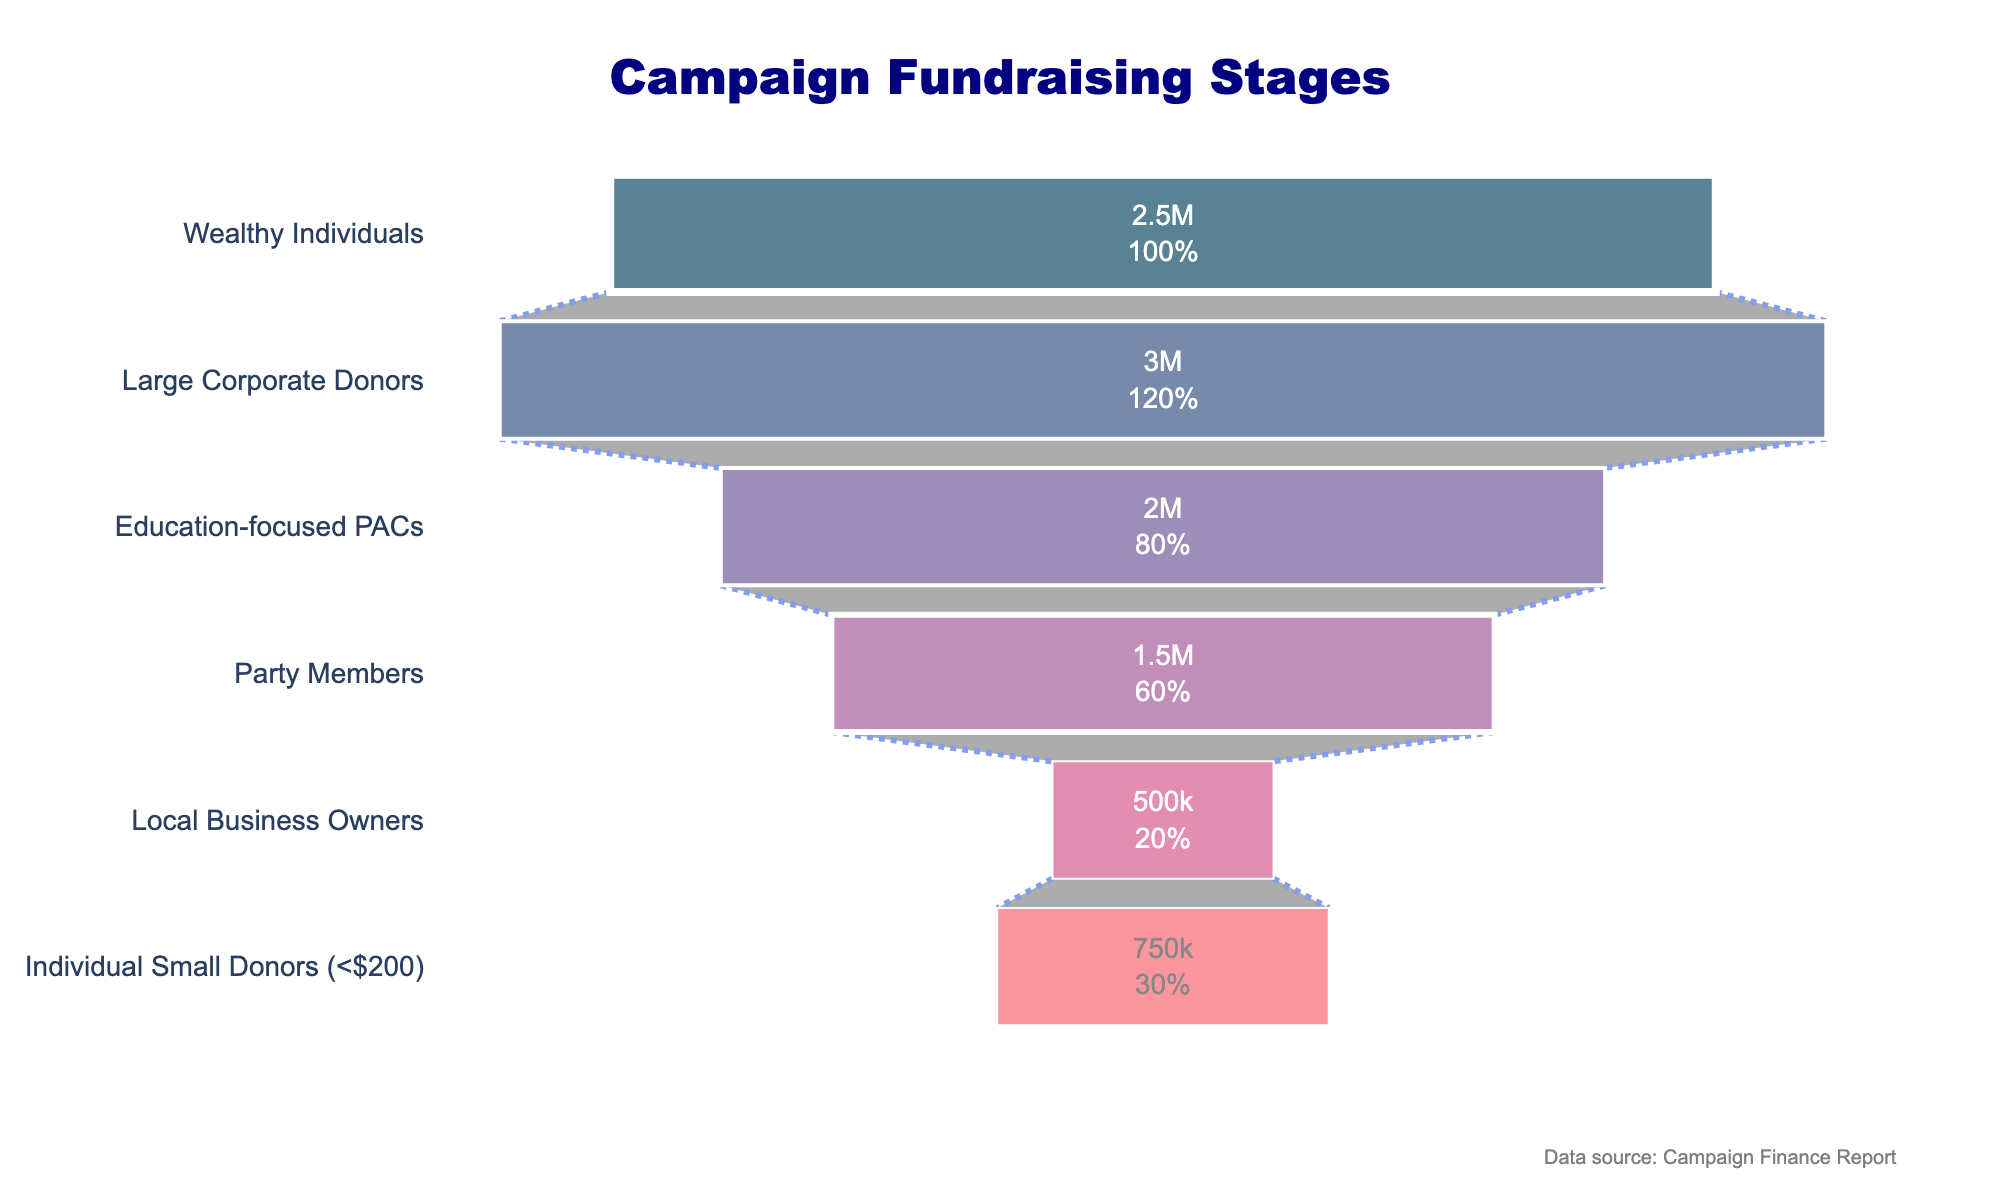What's the title of the funnel chart? The title is typically presented at the top of the chart. It should be concise and summarize the subject of the chart. In this case, the title is "Campaign Fundraising Stages".
Answer: Campaign Fundraising Stages How many stages are represented in the funnel chart? By looking at the number of categories listed horizontally in the funnel chart, we can count the distinct stages.
Answer: 6 Which stage represents the largest contribution in amount? We observe the funnel chart and identify the longest horizontal bar. The stage connected with this bar shows the largest contribution.
Answer: Large Corporate Donors What is the total amount raised from individual small donors and local business owners combined? First, identify the amounts for "Individual Small Donors" and "Local Business Owners" from the chart. Then, add these amounts together: $750,000 + $500,000 = $1,250,000.
Answer: $1,250,000 What percentage of the initial total does the "Large Corporate Donors" stage contribute? Find the amount contributed by "Large Corporate Donors" and the initial total. Use the percentage calculation: (3000000 / 10000000) * 100 = 30%.
Answer: 30% How does the amount contributed by wealthy individuals compare to that of education-focused PACs? Compare the lengths or values of the horizontal bars for "Wealthy Individuals" and "Education-focused PACs". The amount can be directly compared: $2,500,000 (Wealthy Individuals) is $500,000 less than $2,000,000 (Education-focused PACs).
Answer: $500,000 less What's the combined contribution amount from the top three stages? Add the amounts for the top three contributors: $3,000,000 (Large Corporate Donors) + $2,500,000 (Wealthy Individuals) + $2,000,000 (Education-focused PACs). The sum is $7,500,000.
Answer: $7,500,000 Which contributor group has more contributors, Party Members or Local Business Owners? Compare the number of contributors indicated for "Party Members" and "Local Business Owners". "Party Members" have 2,000 contributors, which is more than the 500 of "Local Business Owners".
Answer: Party Members What's the average amount contributed per person by wealthy individuals? Divide the total amount contributed by wealthy individuals by their number: $2,500,000 / 10 = $250,000.
Answer: $250,000 